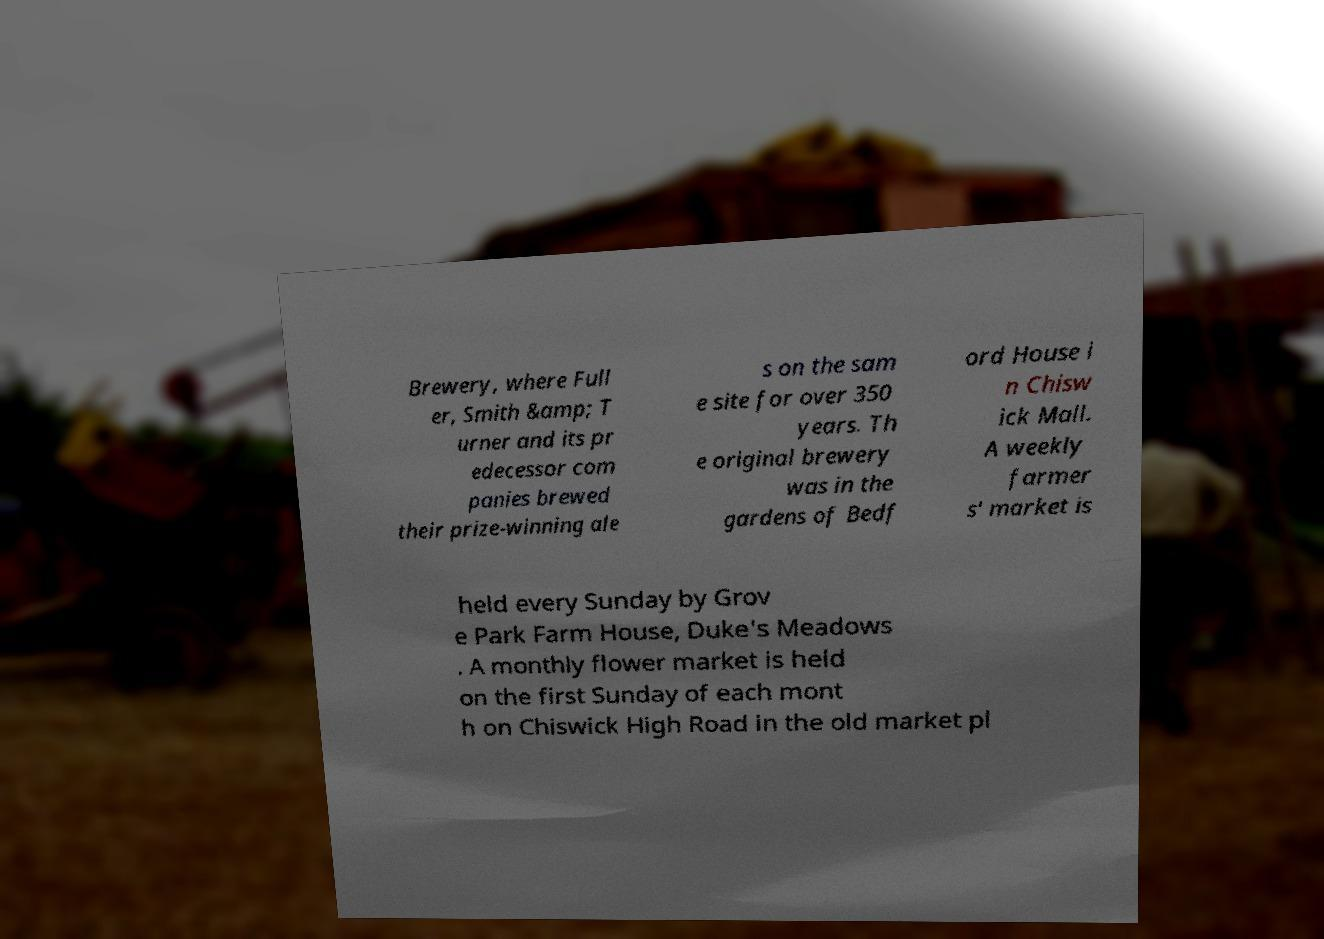Can you read and provide the text displayed in the image?This photo seems to have some interesting text. Can you extract and type it out for me? Brewery, where Full er, Smith &amp; T urner and its pr edecessor com panies brewed their prize-winning ale s on the sam e site for over 350 years. Th e original brewery was in the gardens of Bedf ord House i n Chisw ick Mall. A weekly farmer s' market is held every Sunday by Grov e Park Farm House, Duke's Meadows . A monthly flower market is held on the first Sunday of each mont h on Chiswick High Road in the old market pl 